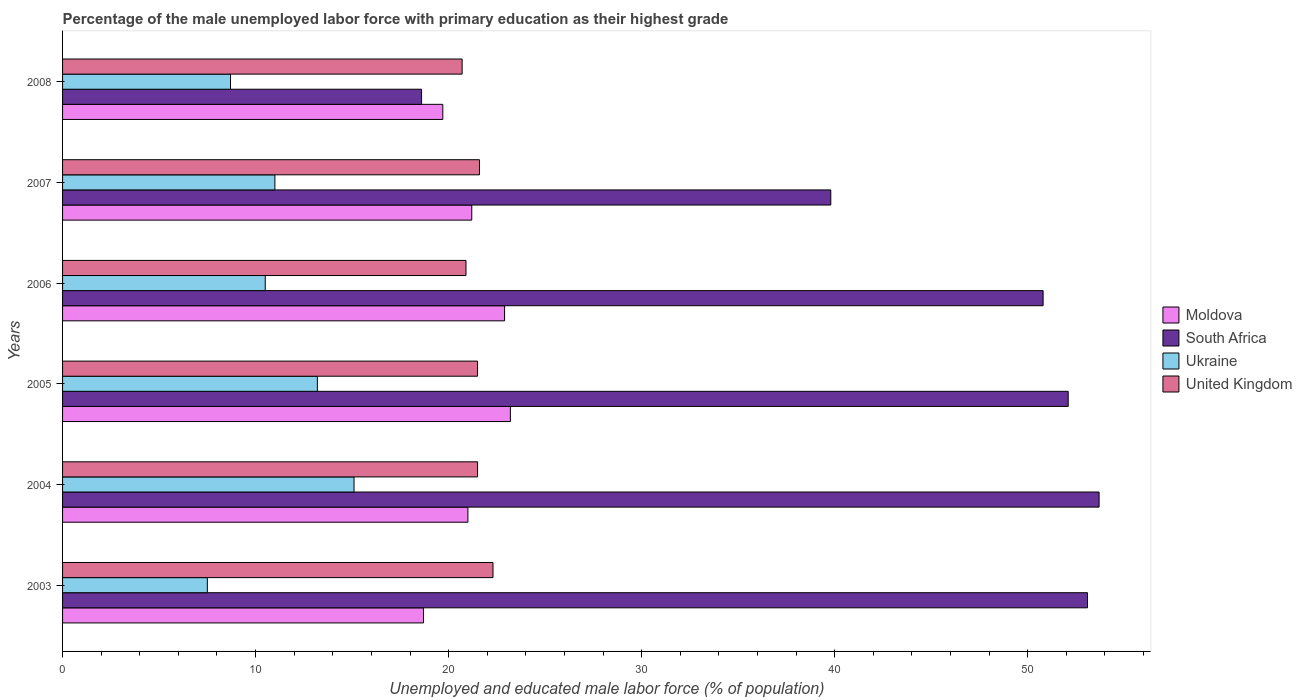How many groups of bars are there?
Provide a short and direct response. 6. How many bars are there on the 5th tick from the bottom?
Give a very brief answer. 4. In how many cases, is the number of bars for a given year not equal to the number of legend labels?
Your answer should be compact. 0. What is the percentage of the unemployed male labor force with primary education in Moldova in 2004?
Give a very brief answer. 21. Across all years, what is the maximum percentage of the unemployed male labor force with primary education in South Africa?
Provide a short and direct response. 53.7. Across all years, what is the minimum percentage of the unemployed male labor force with primary education in United Kingdom?
Your response must be concise. 20.7. In which year was the percentage of the unemployed male labor force with primary education in Ukraine maximum?
Offer a terse response. 2004. What is the total percentage of the unemployed male labor force with primary education in Ukraine in the graph?
Make the answer very short. 66. What is the difference between the percentage of the unemployed male labor force with primary education in United Kingdom in 2006 and that in 2007?
Offer a terse response. -0.7. What is the difference between the percentage of the unemployed male labor force with primary education in Moldova in 2007 and the percentage of the unemployed male labor force with primary education in United Kingdom in 2003?
Provide a short and direct response. -1.1. What is the average percentage of the unemployed male labor force with primary education in Moldova per year?
Make the answer very short. 21.12. In the year 2004, what is the difference between the percentage of the unemployed male labor force with primary education in Ukraine and percentage of the unemployed male labor force with primary education in United Kingdom?
Offer a very short reply. -6.4. In how many years, is the percentage of the unemployed male labor force with primary education in United Kingdom greater than 2 %?
Your response must be concise. 6. What is the ratio of the percentage of the unemployed male labor force with primary education in Moldova in 2005 to that in 2006?
Ensure brevity in your answer.  1.01. Is the percentage of the unemployed male labor force with primary education in United Kingdom in 2007 less than that in 2008?
Provide a succinct answer. No. What is the difference between the highest and the second highest percentage of the unemployed male labor force with primary education in United Kingdom?
Make the answer very short. 0.7. What is the difference between the highest and the lowest percentage of the unemployed male labor force with primary education in Moldova?
Give a very brief answer. 4.5. In how many years, is the percentage of the unemployed male labor force with primary education in Moldova greater than the average percentage of the unemployed male labor force with primary education in Moldova taken over all years?
Make the answer very short. 3. Is it the case that in every year, the sum of the percentage of the unemployed male labor force with primary education in South Africa and percentage of the unemployed male labor force with primary education in United Kingdom is greater than the sum of percentage of the unemployed male labor force with primary education in Ukraine and percentage of the unemployed male labor force with primary education in Moldova?
Give a very brief answer. No. What does the 3rd bar from the top in 2006 represents?
Provide a succinct answer. South Africa. What does the 2nd bar from the bottom in 2008 represents?
Your response must be concise. South Africa. How many bars are there?
Keep it short and to the point. 24. How many years are there in the graph?
Offer a terse response. 6. Does the graph contain any zero values?
Ensure brevity in your answer.  No. Does the graph contain grids?
Your response must be concise. No. Where does the legend appear in the graph?
Your answer should be compact. Center right. How many legend labels are there?
Offer a terse response. 4. How are the legend labels stacked?
Give a very brief answer. Vertical. What is the title of the graph?
Your answer should be compact. Percentage of the male unemployed labor force with primary education as their highest grade. What is the label or title of the X-axis?
Keep it short and to the point. Unemployed and educated male labor force (% of population). What is the label or title of the Y-axis?
Keep it short and to the point. Years. What is the Unemployed and educated male labor force (% of population) of Moldova in 2003?
Provide a succinct answer. 18.7. What is the Unemployed and educated male labor force (% of population) of South Africa in 2003?
Offer a terse response. 53.1. What is the Unemployed and educated male labor force (% of population) in United Kingdom in 2003?
Keep it short and to the point. 22.3. What is the Unemployed and educated male labor force (% of population) of Moldova in 2004?
Keep it short and to the point. 21. What is the Unemployed and educated male labor force (% of population) of South Africa in 2004?
Ensure brevity in your answer.  53.7. What is the Unemployed and educated male labor force (% of population) of Ukraine in 2004?
Your answer should be very brief. 15.1. What is the Unemployed and educated male labor force (% of population) of Moldova in 2005?
Provide a succinct answer. 23.2. What is the Unemployed and educated male labor force (% of population) in South Africa in 2005?
Provide a short and direct response. 52.1. What is the Unemployed and educated male labor force (% of population) of Ukraine in 2005?
Offer a very short reply. 13.2. What is the Unemployed and educated male labor force (% of population) in United Kingdom in 2005?
Ensure brevity in your answer.  21.5. What is the Unemployed and educated male labor force (% of population) in Moldova in 2006?
Offer a terse response. 22.9. What is the Unemployed and educated male labor force (% of population) of South Africa in 2006?
Provide a short and direct response. 50.8. What is the Unemployed and educated male labor force (% of population) in United Kingdom in 2006?
Your response must be concise. 20.9. What is the Unemployed and educated male labor force (% of population) of Moldova in 2007?
Your answer should be compact. 21.2. What is the Unemployed and educated male labor force (% of population) of South Africa in 2007?
Provide a succinct answer. 39.8. What is the Unemployed and educated male labor force (% of population) of United Kingdom in 2007?
Make the answer very short. 21.6. What is the Unemployed and educated male labor force (% of population) of Moldova in 2008?
Keep it short and to the point. 19.7. What is the Unemployed and educated male labor force (% of population) in South Africa in 2008?
Your answer should be very brief. 18.6. What is the Unemployed and educated male labor force (% of population) of Ukraine in 2008?
Your answer should be very brief. 8.7. What is the Unemployed and educated male labor force (% of population) of United Kingdom in 2008?
Offer a terse response. 20.7. Across all years, what is the maximum Unemployed and educated male labor force (% of population) of Moldova?
Provide a short and direct response. 23.2. Across all years, what is the maximum Unemployed and educated male labor force (% of population) of South Africa?
Make the answer very short. 53.7. Across all years, what is the maximum Unemployed and educated male labor force (% of population) in Ukraine?
Keep it short and to the point. 15.1. Across all years, what is the maximum Unemployed and educated male labor force (% of population) of United Kingdom?
Provide a short and direct response. 22.3. Across all years, what is the minimum Unemployed and educated male labor force (% of population) of Moldova?
Give a very brief answer. 18.7. Across all years, what is the minimum Unemployed and educated male labor force (% of population) in South Africa?
Ensure brevity in your answer.  18.6. Across all years, what is the minimum Unemployed and educated male labor force (% of population) in Ukraine?
Ensure brevity in your answer.  7.5. Across all years, what is the minimum Unemployed and educated male labor force (% of population) in United Kingdom?
Give a very brief answer. 20.7. What is the total Unemployed and educated male labor force (% of population) of Moldova in the graph?
Your answer should be very brief. 126.7. What is the total Unemployed and educated male labor force (% of population) of South Africa in the graph?
Make the answer very short. 268.1. What is the total Unemployed and educated male labor force (% of population) in United Kingdom in the graph?
Ensure brevity in your answer.  128.5. What is the difference between the Unemployed and educated male labor force (% of population) in Moldova in 2003 and that in 2004?
Keep it short and to the point. -2.3. What is the difference between the Unemployed and educated male labor force (% of population) in United Kingdom in 2003 and that in 2004?
Make the answer very short. 0.8. What is the difference between the Unemployed and educated male labor force (% of population) of Moldova in 2003 and that in 2005?
Provide a short and direct response. -4.5. What is the difference between the Unemployed and educated male labor force (% of population) in South Africa in 2003 and that in 2005?
Ensure brevity in your answer.  1. What is the difference between the Unemployed and educated male labor force (% of population) of United Kingdom in 2003 and that in 2005?
Your response must be concise. 0.8. What is the difference between the Unemployed and educated male labor force (% of population) in South Africa in 2003 and that in 2006?
Your answer should be compact. 2.3. What is the difference between the Unemployed and educated male labor force (% of population) in Moldova in 2003 and that in 2008?
Ensure brevity in your answer.  -1. What is the difference between the Unemployed and educated male labor force (% of population) in South Africa in 2003 and that in 2008?
Make the answer very short. 34.5. What is the difference between the Unemployed and educated male labor force (% of population) in Ukraine in 2003 and that in 2008?
Give a very brief answer. -1.2. What is the difference between the Unemployed and educated male labor force (% of population) of Moldova in 2004 and that in 2006?
Provide a succinct answer. -1.9. What is the difference between the Unemployed and educated male labor force (% of population) of South Africa in 2004 and that in 2006?
Offer a very short reply. 2.9. What is the difference between the Unemployed and educated male labor force (% of population) in United Kingdom in 2004 and that in 2006?
Provide a short and direct response. 0.6. What is the difference between the Unemployed and educated male labor force (% of population) in Moldova in 2004 and that in 2007?
Your answer should be very brief. -0.2. What is the difference between the Unemployed and educated male labor force (% of population) of South Africa in 2004 and that in 2007?
Your answer should be very brief. 13.9. What is the difference between the Unemployed and educated male labor force (% of population) of United Kingdom in 2004 and that in 2007?
Your response must be concise. -0.1. What is the difference between the Unemployed and educated male labor force (% of population) in South Africa in 2004 and that in 2008?
Provide a succinct answer. 35.1. What is the difference between the Unemployed and educated male labor force (% of population) of Ukraine in 2004 and that in 2008?
Ensure brevity in your answer.  6.4. What is the difference between the Unemployed and educated male labor force (% of population) of Moldova in 2005 and that in 2006?
Your answer should be very brief. 0.3. What is the difference between the Unemployed and educated male labor force (% of population) of South Africa in 2005 and that in 2006?
Keep it short and to the point. 1.3. What is the difference between the Unemployed and educated male labor force (% of population) in United Kingdom in 2005 and that in 2006?
Provide a succinct answer. 0.6. What is the difference between the Unemployed and educated male labor force (% of population) of South Africa in 2005 and that in 2008?
Offer a very short reply. 33.5. What is the difference between the Unemployed and educated male labor force (% of population) of Ukraine in 2005 and that in 2008?
Your answer should be very brief. 4.5. What is the difference between the Unemployed and educated male labor force (% of population) of United Kingdom in 2005 and that in 2008?
Offer a very short reply. 0.8. What is the difference between the Unemployed and educated male labor force (% of population) in South Africa in 2006 and that in 2008?
Make the answer very short. 32.2. What is the difference between the Unemployed and educated male labor force (% of population) in United Kingdom in 2006 and that in 2008?
Your answer should be very brief. 0.2. What is the difference between the Unemployed and educated male labor force (% of population) of Moldova in 2007 and that in 2008?
Offer a very short reply. 1.5. What is the difference between the Unemployed and educated male labor force (% of population) of South Africa in 2007 and that in 2008?
Keep it short and to the point. 21.2. What is the difference between the Unemployed and educated male labor force (% of population) in Moldova in 2003 and the Unemployed and educated male labor force (% of population) in South Africa in 2004?
Make the answer very short. -35. What is the difference between the Unemployed and educated male labor force (% of population) of Moldova in 2003 and the Unemployed and educated male labor force (% of population) of Ukraine in 2004?
Your response must be concise. 3.6. What is the difference between the Unemployed and educated male labor force (% of population) in Moldova in 2003 and the Unemployed and educated male labor force (% of population) in United Kingdom in 2004?
Your response must be concise. -2.8. What is the difference between the Unemployed and educated male labor force (% of population) of South Africa in 2003 and the Unemployed and educated male labor force (% of population) of Ukraine in 2004?
Your answer should be compact. 38. What is the difference between the Unemployed and educated male labor force (% of population) of South Africa in 2003 and the Unemployed and educated male labor force (% of population) of United Kingdom in 2004?
Provide a succinct answer. 31.6. What is the difference between the Unemployed and educated male labor force (% of population) in Ukraine in 2003 and the Unemployed and educated male labor force (% of population) in United Kingdom in 2004?
Your answer should be very brief. -14. What is the difference between the Unemployed and educated male labor force (% of population) in Moldova in 2003 and the Unemployed and educated male labor force (% of population) in South Africa in 2005?
Your response must be concise. -33.4. What is the difference between the Unemployed and educated male labor force (% of population) of South Africa in 2003 and the Unemployed and educated male labor force (% of population) of Ukraine in 2005?
Provide a short and direct response. 39.9. What is the difference between the Unemployed and educated male labor force (% of population) in South Africa in 2003 and the Unemployed and educated male labor force (% of population) in United Kingdom in 2005?
Provide a short and direct response. 31.6. What is the difference between the Unemployed and educated male labor force (% of population) in Moldova in 2003 and the Unemployed and educated male labor force (% of population) in South Africa in 2006?
Keep it short and to the point. -32.1. What is the difference between the Unemployed and educated male labor force (% of population) in Moldova in 2003 and the Unemployed and educated male labor force (% of population) in Ukraine in 2006?
Keep it short and to the point. 8.2. What is the difference between the Unemployed and educated male labor force (% of population) in Moldova in 2003 and the Unemployed and educated male labor force (% of population) in United Kingdom in 2006?
Offer a terse response. -2.2. What is the difference between the Unemployed and educated male labor force (% of population) in South Africa in 2003 and the Unemployed and educated male labor force (% of population) in Ukraine in 2006?
Provide a succinct answer. 42.6. What is the difference between the Unemployed and educated male labor force (% of population) in South Africa in 2003 and the Unemployed and educated male labor force (% of population) in United Kingdom in 2006?
Give a very brief answer. 32.2. What is the difference between the Unemployed and educated male labor force (% of population) in Moldova in 2003 and the Unemployed and educated male labor force (% of population) in South Africa in 2007?
Your answer should be very brief. -21.1. What is the difference between the Unemployed and educated male labor force (% of population) of Moldova in 2003 and the Unemployed and educated male labor force (% of population) of Ukraine in 2007?
Your response must be concise. 7.7. What is the difference between the Unemployed and educated male labor force (% of population) of South Africa in 2003 and the Unemployed and educated male labor force (% of population) of Ukraine in 2007?
Your answer should be very brief. 42.1. What is the difference between the Unemployed and educated male labor force (% of population) of South Africa in 2003 and the Unemployed and educated male labor force (% of population) of United Kingdom in 2007?
Make the answer very short. 31.5. What is the difference between the Unemployed and educated male labor force (% of population) in Ukraine in 2003 and the Unemployed and educated male labor force (% of population) in United Kingdom in 2007?
Keep it short and to the point. -14.1. What is the difference between the Unemployed and educated male labor force (% of population) of Moldova in 2003 and the Unemployed and educated male labor force (% of population) of South Africa in 2008?
Offer a terse response. 0.1. What is the difference between the Unemployed and educated male labor force (% of population) of Moldova in 2003 and the Unemployed and educated male labor force (% of population) of Ukraine in 2008?
Provide a short and direct response. 10. What is the difference between the Unemployed and educated male labor force (% of population) of Moldova in 2003 and the Unemployed and educated male labor force (% of population) of United Kingdom in 2008?
Ensure brevity in your answer.  -2. What is the difference between the Unemployed and educated male labor force (% of population) in South Africa in 2003 and the Unemployed and educated male labor force (% of population) in Ukraine in 2008?
Keep it short and to the point. 44.4. What is the difference between the Unemployed and educated male labor force (% of population) of South Africa in 2003 and the Unemployed and educated male labor force (% of population) of United Kingdom in 2008?
Make the answer very short. 32.4. What is the difference between the Unemployed and educated male labor force (% of population) of Ukraine in 2003 and the Unemployed and educated male labor force (% of population) of United Kingdom in 2008?
Give a very brief answer. -13.2. What is the difference between the Unemployed and educated male labor force (% of population) in Moldova in 2004 and the Unemployed and educated male labor force (% of population) in South Africa in 2005?
Keep it short and to the point. -31.1. What is the difference between the Unemployed and educated male labor force (% of population) in Moldova in 2004 and the Unemployed and educated male labor force (% of population) in Ukraine in 2005?
Ensure brevity in your answer.  7.8. What is the difference between the Unemployed and educated male labor force (% of population) of South Africa in 2004 and the Unemployed and educated male labor force (% of population) of Ukraine in 2005?
Your answer should be very brief. 40.5. What is the difference between the Unemployed and educated male labor force (% of population) of South Africa in 2004 and the Unemployed and educated male labor force (% of population) of United Kingdom in 2005?
Make the answer very short. 32.2. What is the difference between the Unemployed and educated male labor force (% of population) in Moldova in 2004 and the Unemployed and educated male labor force (% of population) in South Africa in 2006?
Keep it short and to the point. -29.8. What is the difference between the Unemployed and educated male labor force (% of population) of Moldova in 2004 and the Unemployed and educated male labor force (% of population) of Ukraine in 2006?
Make the answer very short. 10.5. What is the difference between the Unemployed and educated male labor force (% of population) in Moldova in 2004 and the Unemployed and educated male labor force (% of population) in United Kingdom in 2006?
Your answer should be compact. 0.1. What is the difference between the Unemployed and educated male labor force (% of population) of South Africa in 2004 and the Unemployed and educated male labor force (% of population) of Ukraine in 2006?
Your answer should be very brief. 43.2. What is the difference between the Unemployed and educated male labor force (% of population) of South Africa in 2004 and the Unemployed and educated male labor force (% of population) of United Kingdom in 2006?
Keep it short and to the point. 32.8. What is the difference between the Unemployed and educated male labor force (% of population) of Moldova in 2004 and the Unemployed and educated male labor force (% of population) of South Africa in 2007?
Provide a succinct answer. -18.8. What is the difference between the Unemployed and educated male labor force (% of population) of South Africa in 2004 and the Unemployed and educated male labor force (% of population) of Ukraine in 2007?
Provide a short and direct response. 42.7. What is the difference between the Unemployed and educated male labor force (% of population) of South Africa in 2004 and the Unemployed and educated male labor force (% of population) of United Kingdom in 2007?
Provide a succinct answer. 32.1. What is the difference between the Unemployed and educated male labor force (% of population) in Moldova in 2004 and the Unemployed and educated male labor force (% of population) in South Africa in 2008?
Your answer should be very brief. 2.4. What is the difference between the Unemployed and educated male labor force (% of population) in Moldova in 2004 and the Unemployed and educated male labor force (% of population) in United Kingdom in 2008?
Provide a succinct answer. 0.3. What is the difference between the Unemployed and educated male labor force (% of population) of Ukraine in 2004 and the Unemployed and educated male labor force (% of population) of United Kingdom in 2008?
Offer a very short reply. -5.6. What is the difference between the Unemployed and educated male labor force (% of population) in Moldova in 2005 and the Unemployed and educated male labor force (% of population) in South Africa in 2006?
Give a very brief answer. -27.6. What is the difference between the Unemployed and educated male labor force (% of population) in Moldova in 2005 and the Unemployed and educated male labor force (% of population) in Ukraine in 2006?
Give a very brief answer. 12.7. What is the difference between the Unemployed and educated male labor force (% of population) in South Africa in 2005 and the Unemployed and educated male labor force (% of population) in Ukraine in 2006?
Provide a succinct answer. 41.6. What is the difference between the Unemployed and educated male labor force (% of population) of South Africa in 2005 and the Unemployed and educated male labor force (% of population) of United Kingdom in 2006?
Your answer should be very brief. 31.2. What is the difference between the Unemployed and educated male labor force (% of population) in Moldova in 2005 and the Unemployed and educated male labor force (% of population) in South Africa in 2007?
Ensure brevity in your answer.  -16.6. What is the difference between the Unemployed and educated male labor force (% of population) of South Africa in 2005 and the Unemployed and educated male labor force (% of population) of Ukraine in 2007?
Provide a short and direct response. 41.1. What is the difference between the Unemployed and educated male labor force (% of population) in South Africa in 2005 and the Unemployed and educated male labor force (% of population) in United Kingdom in 2007?
Your response must be concise. 30.5. What is the difference between the Unemployed and educated male labor force (% of population) of Ukraine in 2005 and the Unemployed and educated male labor force (% of population) of United Kingdom in 2007?
Ensure brevity in your answer.  -8.4. What is the difference between the Unemployed and educated male labor force (% of population) of Moldova in 2005 and the Unemployed and educated male labor force (% of population) of South Africa in 2008?
Your answer should be compact. 4.6. What is the difference between the Unemployed and educated male labor force (% of population) in Moldova in 2005 and the Unemployed and educated male labor force (% of population) in Ukraine in 2008?
Your response must be concise. 14.5. What is the difference between the Unemployed and educated male labor force (% of population) of South Africa in 2005 and the Unemployed and educated male labor force (% of population) of Ukraine in 2008?
Offer a terse response. 43.4. What is the difference between the Unemployed and educated male labor force (% of population) in South Africa in 2005 and the Unemployed and educated male labor force (% of population) in United Kingdom in 2008?
Keep it short and to the point. 31.4. What is the difference between the Unemployed and educated male labor force (% of population) of Ukraine in 2005 and the Unemployed and educated male labor force (% of population) of United Kingdom in 2008?
Offer a terse response. -7.5. What is the difference between the Unemployed and educated male labor force (% of population) of Moldova in 2006 and the Unemployed and educated male labor force (% of population) of South Africa in 2007?
Ensure brevity in your answer.  -16.9. What is the difference between the Unemployed and educated male labor force (% of population) in South Africa in 2006 and the Unemployed and educated male labor force (% of population) in Ukraine in 2007?
Offer a terse response. 39.8. What is the difference between the Unemployed and educated male labor force (% of population) of South Africa in 2006 and the Unemployed and educated male labor force (% of population) of United Kingdom in 2007?
Keep it short and to the point. 29.2. What is the difference between the Unemployed and educated male labor force (% of population) of South Africa in 2006 and the Unemployed and educated male labor force (% of population) of Ukraine in 2008?
Offer a terse response. 42.1. What is the difference between the Unemployed and educated male labor force (% of population) of South Africa in 2006 and the Unemployed and educated male labor force (% of population) of United Kingdom in 2008?
Offer a terse response. 30.1. What is the difference between the Unemployed and educated male labor force (% of population) in Ukraine in 2006 and the Unemployed and educated male labor force (% of population) in United Kingdom in 2008?
Offer a terse response. -10.2. What is the difference between the Unemployed and educated male labor force (% of population) of Moldova in 2007 and the Unemployed and educated male labor force (% of population) of South Africa in 2008?
Provide a succinct answer. 2.6. What is the difference between the Unemployed and educated male labor force (% of population) in Moldova in 2007 and the Unemployed and educated male labor force (% of population) in United Kingdom in 2008?
Your answer should be compact. 0.5. What is the difference between the Unemployed and educated male labor force (% of population) in South Africa in 2007 and the Unemployed and educated male labor force (% of population) in Ukraine in 2008?
Make the answer very short. 31.1. What is the difference between the Unemployed and educated male labor force (% of population) of South Africa in 2007 and the Unemployed and educated male labor force (% of population) of United Kingdom in 2008?
Offer a terse response. 19.1. What is the average Unemployed and educated male labor force (% of population) in Moldova per year?
Keep it short and to the point. 21.12. What is the average Unemployed and educated male labor force (% of population) in South Africa per year?
Offer a terse response. 44.68. What is the average Unemployed and educated male labor force (% of population) in Ukraine per year?
Your answer should be very brief. 11. What is the average Unemployed and educated male labor force (% of population) of United Kingdom per year?
Provide a short and direct response. 21.42. In the year 2003, what is the difference between the Unemployed and educated male labor force (% of population) in Moldova and Unemployed and educated male labor force (% of population) in South Africa?
Ensure brevity in your answer.  -34.4. In the year 2003, what is the difference between the Unemployed and educated male labor force (% of population) in South Africa and Unemployed and educated male labor force (% of population) in Ukraine?
Give a very brief answer. 45.6. In the year 2003, what is the difference between the Unemployed and educated male labor force (% of population) of South Africa and Unemployed and educated male labor force (% of population) of United Kingdom?
Ensure brevity in your answer.  30.8. In the year 2003, what is the difference between the Unemployed and educated male labor force (% of population) of Ukraine and Unemployed and educated male labor force (% of population) of United Kingdom?
Your answer should be compact. -14.8. In the year 2004, what is the difference between the Unemployed and educated male labor force (% of population) in Moldova and Unemployed and educated male labor force (% of population) in South Africa?
Your answer should be very brief. -32.7. In the year 2004, what is the difference between the Unemployed and educated male labor force (% of population) of Moldova and Unemployed and educated male labor force (% of population) of Ukraine?
Make the answer very short. 5.9. In the year 2004, what is the difference between the Unemployed and educated male labor force (% of population) in Moldova and Unemployed and educated male labor force (% of population) in United Kingdom?
Provide a short and direct response. -0.5. In the year 2004, what is the difference between the Unemployed and educated male labor force (% of population) of South Africa and Unemployed and educated male labor force (% of population) of Ukraine?
Provide a succinct answer. 38.6. In the year 2004, what is the difference between the Unemployed and educated male labor force (% of population) of South Africa and Unemployed and educated male labor force (% of population) of United Kingdom?
Make the answer very short. 32.2. In the year 2004, what is the difference between the Unemployed and educated male labor force (% of population) of Ukraine and Unemployed and educated male labor force (% of population) of United Kingdom?
Provide a succinct answer. -6.4. In the year 2005, what is the difference between the Unemployed and educated male labor force (% of population) of Moldova and Unemployed and educated male labor force (% of population) of South Africa?
Keep it short and to the point. -28.9. In the year 2005, what is the difference between the Unemployed and educated male labor force (% of population) in South Africa and Unemployed and educated male labor force (% of population) in Ukraine?
Offer a terse response. 38.9. In the year 2005, what is the difference between the Unemployed and educated male labor force (% of population) of South Africa and Unemployed and educated male labor force (% of population) of United Kingdom?
Keep it short and to the point. 30.6. In the year 2006, what is the difference between the Unemployed and educated male labor force (% of population) in Moldova and Unemployed and educated male labor force (% of population) in South Africa?
Your answer should be very brief. -27.9. In the year 2006, what is the difference between the Unemployed and educated male labor force (% of population) of Moldova and Unemployed and educated male labor force (% of population) of Ukraine?
Your answer should be very brief. 12.4. In the year 2006, what is the difference between the Unemployed and educated male labor force (% of population) of Moldova and Unemployed and educated male labor force (% of population) of United Kingdom?
Offer a terse response. 2. In the year 2006, what is the difference between the Unemployed and educated male labor force (% of population) of South Africa and Unemployed and educated male labor force (% of population) of Ukraine?
Offer a terse response. 40.3. In the year 2006, what is the difference between the Unemployed and educated male labor force (% of population) in South Africa and Unemployed and educated male labor force (% of population) in United Kingdom?
Offer a very short reply. 29.9. In the year 2006, what is the difference between the Unemployed and educated male labor force (% of population) in Ukraine and Unemployed and educated male labor force (% of population) in United Kingdom?
Make the answer very short. -10.4. In the year 2007, what is the difference between the Unemployed and educated male labor force (% of population) of Moldova and Unemployed and educated male labor force (% of population) of South Africa?
Make the answer very short. -18.6. In the year 2007, what is the difference between the Unemployed and educated male labor force (% of population) in South Africa and Unemployed and educated male labor force (% of population) in Ukraine?
Give a very brief answer. 28.8. In the year 2007, what is the difference between the Unemployed and educated male labor force (% of population) in Ukraine and Unemployed and educated male labor force (% of population) in United Kingdom?
Provide a short and direct response. -10.6. In the year 2008, what is the difference between the Unemployed and educated male labor force (% of population) in Moldova and Unemployed and educated male labor force (% of population) in Ukraine?
Make the answer very short. 11. In the year 2008, what is the difference between the Unemployed and educated male labor force (% of population) in South Africa and Unemployed and educated male labor force (% of population) in Ukraine?
Your answer should be very brief. 9.9. In the year 2008, what is the difference between the Unemployed and educated male labor force (% of population) in South Africa and Unemployed and educated male labor force (% of population) in United Kingdom?
Keep it short and to the point. -2.1. In the year 2008, what is the difference between the Unemployed and educated male labor force (% of population) in Ukraine and Unemployed and educated male labor force (% of population) in United Kingdom?
Provide a succinct answer. -12. What is the ratio of the Unemployed and educated male labor force (% of population) of Moldova in 2003 to that in 2004?
Keep it short and to the point. 0.89. What is the ratio of the Unemployed and educated male labor force (% of population) of South Africa in 2003 to that in 2004?
Ensure brevity in your answer.  0.99. What is the ratio of the Unemployed and educated male labor force (% of population) of Ukraine in 2003 to that in 2004?
Make the answer very short. 0.5. What is the ratio of the Unemployed and educated male labor force (% of population) in United Kingdom in 2003 to that in 2004?
Your answer should be compact. 1.04. What is the ratio of the Unemployed and educated male labor force (% of population) in Moldova in 2003 to that in 2005?
Keep it short and to the point. 0.81. What is the ratio of the Unemployed and educated male labor force (% of population) of South Africa in 2003 to that in 2005?
Give a very brief answer. 1.02. What is the ratio of the Unemployed and educated male labor force (% of population) of Ukraine in 2003 to that in 2005?
Give a very brief answer. 0.57. What is the ratio of the Unemployed and educated male labor force (% of population) in United Kingdom in 2003 to that in 2005?
Offer a very short reply. 1.04. What is the ratio of the Unemployed and educated male labor force (% of population) in Moldova in 2003 to that in 2006?
Your answer should be compact. 0.82. What is the ratio of the Unemployed and educated male labor force (% of population) in South Africa in 2003 to that in 2006?
Make the answer very short. 1.05. What is the ratio of the Unemployed and educated male labor force (% of population) of Ukraine in 2003 to that in 2006?
Your answer should be compact. 0.71. What is the ratio of the Unemployed and educated male labor force (% of population) of United Kingdom in 2003 to that in 2006?
Give a very brief answer. 1.07. What is the ratio of the Unemployed and educated male labor force (% of population) in Moldova in 2003 to that in 2007?
Ensure brevity in your answer.  0.88. What is the ratio of the Unemployed and educated male labor force (% of population) of South Africa in 2003 to that in 2007?
Keep it short and to the point. 1.33. What is the ratio of the Unemployed and educated male labor force (% of population) of Ukraine in 2003 to that in 2007?
Provide a short and direct response. 0.68. What is the ratio of the Unemployed and educated male labor force (% of population) in United Kingdom in 2003 to that in 2007?
Your response must be concise. 1.03. What is the ratio of the Unemployed and educated male labor force (% of population) of Moldova in 2003 to that in 2008?
Your answer should be very brief. 0.95. What is the ratio of the Unemployed and educated male labor force (% of population) of South Africa in 2003 to that in 2008?
Your answer should be compact. 2.85. What is the ratio of the Unemployed and educated male labor force (% of population) in Ukraine in 2003 to that in 2008?
Provide a short and direct response. 0.86. What is the ratio of the Unemployed and educated male labor force (% of population) in United Kingdom in 2003 to that in 2008?
Offer a very short reply. 1.08. What is the ratio of the Unemployed and educated male labor force (% of population) of Moldova in 2004 to that in 2005?
Provide a short and direct response. 0.91. What is the ratio of the Unemployed and educated male labor force (% of population) in South Africa in 2004 to that in 2005?
Your response must be concise. 1.03. What is the ratio of the Unemployed and educated male labor force (% of population) of Ukraine in 2004 to that in 2005?
Give a very brief answer. 1.14. What is the ratio of the Unemployed and educated male labor force (% of population) in United Kingdom in 2004 to that in 2005?
Provide a short and direct response. 1. What is the ratio of the Unemployed and educated male labor force (% of population) in Moldova in 2004 to that in 2006?
Give a very brief answer. 0.92. What is the ratio of the Unemployed and educated male labor force (% of population) of South Africa in 2004 to that in 2006?
Ensure brevity in your answer.  1.06. What is the ratio of the Unemployed and educated male labor force (% of population) of Ukraine in 2004 to that in 2006?
Provide a succinct answer. 1.44. What is the ratio of the Unemployed and educated male labor force (% of population) in United Kingdom in 2004 to that in 2006?
Offer a terse response. 1.03. What is the ratio of the Unemployed and educated male labor force (% of population) of Moldova in 2004 to that in 2007?
Make the answer very short. 0.99. What is the ratio of the Unemployed and educated male labor force (% of population) in South Africa in 2004 to that in 2007?
Offer a very short reply. 1.35. What is the ratio of the Unemployed and educated male labor force (% of population) in Ukraine in 2004 to that in 2007?
Offer a terse response. 1.37. What is the ratio of the Unemployed and educated male labor force (% of population) of Moldova in 2004 to that in 2008?
Your answer should be very brief. 1.07. What is the ratio of the Unemployed and educated male labor force (% of population) of South Africa in 2004 to that in 2008?
Provide a succinct answer. 2.89. What is the ratio of the Unemployed and educated male labor force (% of population) of Ukraine in 2004 to that in 2008?
Your response must be concise. 1.74. What is the ratio of the Unemployed and educated male labor force (% of population) of United Kingdom in 2004 to that in 2008?
Your answer should be compact. 1.04. What is the ratio of the Unemployed and educated male labor force (% of population) of Moldova in 2005 to that in 2006?
Make the answer very short. 1.01. What is the ratio of the Unemployed and educated male labor force (% of population) in South Africa in 2005 to that in 2006?
Offer a terse response. 1.03. What is the ratio of the Unemployed and educated male labor force (% of population) of Ukraine in 2005 to that in 2006?
Ensure brevity in your answer.  1.26. What is the ratio of the Unemployed and educated male labor force (% of population) of United Kingdom in 2005 to that in 2006?
Provide a succinct answer. 1.03. What is the ratio of the Unemployed and educated male labor force (% of population) of Moldova in 2005 to that in 2007?
Give a very brief answer. 1.09. What is the ratio of the Unemployed and educated male labor force (% of population) of South Africa in 2005 to that in 2007?
Give a very brief answer. 1.31. What is the ratio of the Unemployed and educated male labor force (% of population) of Ukraine in 2005 to that in 2007?
Keep it short and to the point. 1.2. What is the ratio of the Unemployed and educated male labor force (% of population) in United Kingdom in 2005 to that in 2007?
Provide a short and direct response. 1. What is the ratio of the Unemployed and educated male labor force (% of population) of Moldova in 2005 to that in 2008?
Provide a short and direct response. 1.18. What is the ratio of the Unemployed and educated male labor force (% of population) of South Africa in 2005 to that in 2008?
Make the answer very short. 2.8. What is the ratio of the Unemployed and educated male labor force (% of population) in Ukraine in 2005 to that in 2008?
Make the answer very short. 1.52. What is the ratio of the Unemployed and educated male labor force (% of population) of United Kingdom in 2005 to that in 2008?
Provide a short and direct response. 1.04. What is the ratio of the Unemployed and educated male labor force (% of population) of Moldova in 2006 to that in 2007?
Your response must be concise. 1.08. What is the ratio of the Unemployed and educated male labor force (% of population) of South Africa in 2006 to that in 2007?
Offer a terse response. 1.28. What is the ratio of the Unemployed and educated male labor force (% of population) of Ukraine in 2006 to that in 2007?
Offer a terse response. 0.95. What is the ratio of the Unemployed and educated male labor force (% of population) in United Kingdom in 2006 to that in 2007?
Your answer should be very brief. 0.97. What is the ratio of the Unemployed and educated male labor force (% of population) in Moldova in 2006 to that in 2008?
Ensure brevity in your answer.  1.16. What is the ratio of the Unemployed and educated male labor force (% of population) in South Africa in 2006 to that in 2008?
Your answer should be very brief. 2.73. What is the ratio of the Unemployed and educated male labor force (% of population) of Ukraine in 2006 to that in 2008?
Offer a very short reply. 1.21. What is the ratio of the Unemployed and educated male labor force (% of population) of United Kingdom in 2006 to that in 2008?
Your answer should be compact. 1.01. What is the ratio of the Unemployed and educated male labor force (% of population) in Moldova in 2007 to that in 2008?
Ensure brevity in your answer.  1.08. What is the ratio of the Unemployed and educated male labor force (% of population) of South Africa in 2007 to that in 2008?
Ensure brevity in your answer.  2.14. What is the ratio of the Unemployed and educated male labor force (% of population) of Ukraine in 2007 to that in 2008?
Give a very brief answer. 1.26. What is the ratio of the Unemployed and educated male labor force (% of population) of United Kingdom in 2007 to that in 2008?
Your answer should be compact. 1.04. What is the difference between the highest and the second highest Unemployed and educated male labor force (% of population) in Moldova?
Keep it short and to the point. 0.3. What is the difference between the highest and the second highest Unemployed and educated male labor force (% of population) of South Africa?
Make the answer very short. 0.6. What is the difference between the highest and the second highest Unemployed and educated male labor force (% of population) of United Kingdom?
Ensure brevity in your answer.  0.7. What is the difference between the highest and the lowest Unemployed and educated male labor force (% of population) in Moldova?
Make the answer very short. 4.5. What is the difference between the highest and the lowest Unemployed and educated male labor force (% of population) in South Africa?
Offer a very short reply. 35.1. What is the difference between the highest and the lowest Unemployed and educated male labor force (% of population) in United Kingdom?
Offer a very short reply. 1.6. 